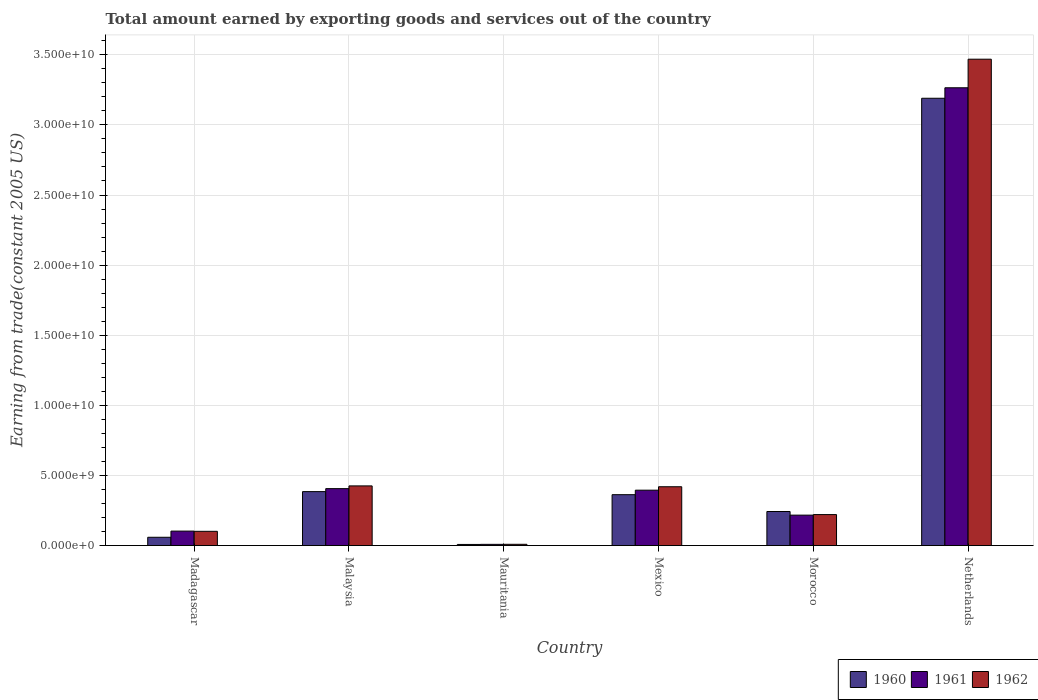How many different coloured bars are there?
Provide a short and direct response. 3. How many groups of bars are there?
Your response must be concise. 6. Are the number of bars on each tick of the X-axis equal?
Offer a terse response. Yes. How many bars are there on the 1st tick from the left?
Give a very brief answer. 3. How many bars are there on the 6th tick from the right?
Your answer should be very brief. 3. What is the label of the 3rd group of bars from the left?
Provide a succinct answer. Mauritania. What is the total amount earned by exporting goods and services in 1962 in Netherlands?
Keep it short and to the point. 3.47e+1. Across all countries, what is the maximum total amount earned by exporting goods and services in 1960?
Provide a short and direct response. 3.19e+1. Across all countries, what is the minimum total amount earned by exporting goods and services in 1962?
Make the answer very short. 8.95e+07. In which country was the total amount earned by exporting goods and services in 1961 maximum?
Provide a succinct answer. Netherlands. In which country was the total amount earned by exporting goods and services in 1961 minimum?
Your answer should be compact. Mauritania. What is the total total amount earned by exporting goods and services in 1961 in the graph?
Your answer should be very brief. 4.39e+1. What is the difference between the total amount earned by exporting goods and services in 1962 in Malaysia and that in Netherlands?
Provide a short and direct response. -3.04e+1. What is the difference between the total amount earned by exporting goods and services in 1961 in Mexico and the total amount earned by exporting goods and services in 1962 in Morocco?
Provide a succinct answer. 1.74e+09. What is the average total amount earned by exporting goods and services in 1961 per country?
Give a very brief answer. 7.32e+09. What is the difference between the total amount earned by exporting goods and services of/in 1960 and total amount earned by exporting goods and services of/in 1961 in Morocco?
Give a very brief answer. 2.59e+08. What is the ratio of the total amount earned by exporting goods and services in 1962 in Mexico to that in Netherlands?
Provide a short and direct response. 0.12. Is the difference between the total amount earned by exporting goods and services in 1960 in Madagascar and Mauritania greater than the difference between the total amount earned by exporting goods and services in 1961 in Madagascar and Mauritania?
Keep it short and to the point. No. What is the difference between the highest and the second highest total amount earned by exporting goods and services in 1961?
Ensure brevity in your answer.  1.10e+08. What is the difference between the highest and the lowest total amount earned by exporting goods and services in 1961?
Ensure brevity in your answer.  3.26e+1. In how many countries, is the total amount earned by exporting goods and services in 1962 greater than the average total amount earned by exporting goods and services in 1962 taken over all countries?
Ensure brevity in your answer.  1. Is the sum of the total amount earned by exporting goods and services in 1960 in Madagascar and Mexico greater than the maximum total amount earned by exporting goods and services in 1962 across all countries?
Keep it short and to the point. No. What does the 3rd bar from the left in Malaysia represents?
Make the answer very short. 1962. How many countries are there in the graph?
Offer a terse response. 6. Does the graph contain any zero values?
Offer a terse response. No. What is the title of the graph?
Ensure brevity in your answer.  Total amount earned by exporting goods and services out of the country. What is the label or title of the Y-axis?
Make the answer very short. Earning from trade(constant 2005 US). What is the Earning from trade(constant 2005 US) in 1960 in Madagascar?
Make the answer very short. 5.92e+08. What is the Earning from trade(constant 2005 US) of 1961 in Madagascar?
Make the answer very short. 1.03e+09. What is the Earning from trade(constant 2005 US) in 1962 in Madagascar?
Make the answer very short. 1.02e+09. What is the Earning from trade(constant 2005 US) of 1960 in Malaysia?
Provide a short and direct response. 3.85e+09. What is the Earning from trade(constant 2005 US) in 1961 in Malaysia?
Offer a very short reply. 4.06e+09. What is the Earning from trade(constant 2005 US) in 1962 in Malaysia?
Provide a succinct answer. 4.25e+09. What is the Earning from trade(constant 2005 US) in 1960 in Mauritania?
Provide a succinct answer. 7.97e+07. What is the Earning from trade(constant 2005 US) of 1961 in Mauritania?
Offer a very short reply. 8.64e+07. What is the Earning from trade(constant 2005 US) in 1962 in Mauritania?
Your response must be concise. 8.95e+07. What is the Earning from trade(constant 2005 US) in 1960 in Mexico?
Your response must be concise. 3.63e+09. What is the Earning from trade(constant 2005 US) of 1961 in Mexico?
Your answer should be compact. 3.95e+09. What is the Earning from trade(constant 2005 US) of 1962 in Mexico?
Provide a short and direct response. 4.19e+09. What is the Earning from trade(constant 2005 US) of 1960 in Morocco?
Provide a succinct answer. 2.43e+09. What is the Earning from trade(constant 2005 US) in 1961 in Morocco?
Keep it short and to the point. 2.17e+09. What is the Earning from trade(constant 2005 US) in 1962 in Morocco?
Give a very brief answer. 2.21e+09. What is the Earning from trade(constant 2005 US) in 1960 in Netherlands?
Ensure brevity in your answer.  3.19e+1. What is the Earning from trade(constant 2005 US) of 1961 in Netherlands?
Offer a terse response. 3.26e+1. What is the Earning from trade(constant 2005 US) of 1962 in Netherlands?
Give a very brief answer. 3.47e+1. Across all countries, what is the maximum Earning from trade(constant 2005 US) in 1960?
Keep it short and to the point. 3.19e+1. Across all countries, what is the maximum Earning from trade(constant 2005 US) of 1961?
Give a very brief answer. 3.26e+1. Across all countries, what is the maximum Earning from trade(constant 2005 US) of 1962?
Your answer should be compact. 3.47e+1. Across all countries, what is the minimum Earning from trade(constant 2005 US) in 1960?
Offer a terse response. 7.97e+07. Across all countries, what is the minimum Earning from trade(constant 2005 US) of 1961?
Your response must be concise. 8.64e+07. Across all countries, what is the minimum Earning from trade(constant 2005 US) of 1962?
Your answer should be very brief. 8.95e+07. What is the total Earning from trade(constant 2005 US) of 1960 in the graph?
Offer a terse response. 4.25e+1. What is the total Earning from trade(constant 2005 US) in 1961 in the graph?
Your answer should be very brief. 4.39e+1. What is the total Earning from trade(constant 2005 US) of 1962 in the graph?
Make the answer very short. 4.64e+1. What is the difference between the Earning from trade(constant 2005 US) of 1960 in Madagascar and that in Malaysia?
Provide a succinct answer. -3.26e+09. What is the difference between the Earning from trade(constant 2005 US) of 1961 in Madagascar and that in Malaysia?
Provide a short and direct response. -3.03e+09. What is the difference between the Earning from trade(constant 2005 US) of 1962 in Madagascar and that in Malaysia?
Your response must be concise. -3.24e+09. What is the difference between the Earning from trade(constant 2005 US) in 1960 in Madagascar and that in Mauritania?
Offer a terse response. 5.12e+08. What is the difference between the Earning from trade(constant 2005 US) in 1961 in Madagascar and that in Mauritania?
Offer a very short reply. 9.45e+08. What is the difference between the Earning from trade(constant 2005 US) in 1962 in Madagascar and that in Mauritania?
Ensure brevity in your answer.  9.26e+08. What is the difference between the Earning from trade(constant 2005 US) in 1960 in Madagascar and that in Mexico?
Offer a very short reply. -3.04e+09. What is the difference between the Earning from trade(constant 2005 US) in 1961 in Madagascar and that in Mexico?
Keep it short and to the point. -2.92e+09. What is the difference between the Earning from trade(constant 2005 US) of 1962 in Madagascar and that in Mexico?
Keep it short and to the point. -3.18e+09. What is the difference between the Earning from trade(constant 2005 US) in 1960 in Madagascar and that in Morocco?
Ensure brevity in your answer.  -1.84e+09. What is the difference between the Earning from trade(constant 2005 US) in 1961 in Madagascar and that in Morocco?
Make the answer very short. -1.14e+09. What is the difference between the Earning from trade(constant 2005 US) of 1962 in Madagascar and that in Morocco?
Your response must be concise. -1.19e+09. What is the difference between the Earning from trade(constant 2005 US) of 1960 in Madagascar and that in Netherlands?
Provide a short and direct response. -3.13e+1. What is the difference between the Earning from trade(constant 2005 US) in 1961 in Madagascar and that in Netherlands?
Provide a short and direct response. -3.16e+1. What is the difference between the Earning from trade(constant 2005 US) in 1962 in Madagascar and that in Netherlands?
Provide a succinct answer. -3.37e+1. What is the difference between the Earning from trade(constant 2005 US) in 1960 in Malaysia and that in Mauritania?
Give a very brief answer. 3.77e+09. What is the difference between the Earning from trade(constant 2005 US) in 1961 in Malaysia and that in Mauritania?
Keep it short and to the point. 3.97e+09. What is the difference between the Earning from trade(constant 2005 US) of 1962 in Malaysia and that in Mauritania?
Offer a very short reply. 4.17e+09. What is the difference between the Earning from trade(constant 2005 US) in 1960 in Malaysia and that in Mexico?
Give a very brief answer. 2.18e+08. What is the difference between the Earning from trade(constant 2005 US) in 1961 in Malaysia and that in Mexico?
Your answer should be compact. 1.10e+08. What is the difference between the Earning from trade(constant 2005 US) in 1962 in Malaysia and that in Mexico?
Provide a succinct answer. 6.04e+07. What is the difference between the Earning from trade(constant 2005 US) of 1960 in Malaysia and that in Morocco?
Give a very brief answer. 1.42e+09. What is the difference between the Earning from trade(constant 2005 US) in 1961 in Malaysia and that in Morocco?
Your answer should be compact. 1.89e+09. What is the difference between the Earning from trade(constant 2005 US) in 1962 in Malaysia and that in Morocco?
Keep it short and to the point. 2.05e+09. What is the difference between the Earning from trade(constant 2005 US) in 1960 in Malaysia and that in Netherlands?
Provide a short and direct response. -2.81e+1. What is the difference between the Earning from trade(constant 2005 US) of 1961 in Malaysia and that in Netherlands?
Offer a terse response. -2.86e+1. What is the difference between the Earning from trade(constant 2005 US) of 1962 in Malaysia and that in Netherlands?
Make the answer very short. -3.04e+1. What is the difference between the Earning from trade(constant 2005 US) of 1960 in Mauritania and that in Mexico?
Make the answer very short. -3.55e+09. What is the difference between the Earning from trade(constant 2005 US) of 1961 in Mauritania and that in Mexico?
Provide a succinct answer. -3.86e+09. What is the difference between the Earning from trade(constant 2005 US) of 1962 in Mauritania and that in Mexico?
Keep it short and to the point. -4.10e+09. What is the difference between the Earning from trade(constant 2005 US) of 1960 in Mauritania and that in Morocco?
Your response must be concise. -2.35e+09. What is the difference between the Earning from trade(constant 2005 US) of 1961 in Mauritania and that in Morocco?
Give a very brief answer. -2.08e+09. What is the difference between the Earning from trade(constant 2005 US) of 1962 in Mauritania and that in Morocco?
Your response must be concise. -2.12e+09. What is the difference between the Earning from trade(constant 2005 US) of 1960 in Mauritania and that in Netherlands?
Your answer should be compact. -3.18e+1. What is the difference between the Earning from trade(constant 2005 US) in 1961 in Mauritania and that in Netherlands?
Offer a terse response. -3.26e+1. What is the difference between the Earning from trade(constant 2005 US) of 1962 in Mauritania and that in Netherlands?
Make the answer very short. -3.46e+1. What is the difference between the Earning from trade(constant 2005 US) of 1960 in Mexico and that in Morocco?
Make the answer very short. 1.20e+09. What is the difference between the Earning from trade(constant 2005 US) in 1961 in Mexico and that in Morocco?
Give a very brief answer. 1.78e+09. What is the difference between the Earning from trade(constant 2005 US) in 1962 in Mexico and that in Morocco?
Ensure brevity in your answer.  1.99e+09. What is the difference between the Earning from trade(constant 2005 US) of 1960 in Mexico and that in Netherlands?
Ensure brevity in your answer.  -2.83e+1. What is the difference between the Earning from trade(constant 2005 US) in 1961 in Mexico and that in Netherlands?
Offer a terse response. -2.87e+1. What is the difference between the Earning from trade(constant 2005 US) of 1962 in Mexico and that in Netherlands?
Offer a very short reply. -3.05e+1. What is the difference between the Earning from trade(constant 2005 US) of 1960 in Morocco and that in Netherlands?
Offer a very short reply. -2.95e+1. What is the difference between the Earning from trade(constant 2005 US) of 1961 in Morocco and that in Netherlands?
Ensure brevity in your answer.  -3.05e+1. What is the difference between the Earning from trade(constant 2005 US) in 1962 in Morocco and that in Netherlands?
Ensure brevity in your answer.  -3.25e+1. What is the difference between the Earning from trade(constant 2005 US) of 1960 in Madagascar and the Earning from trade(constant 2005 US) of 1961 in Malaysia?
Ensure brevity in your answer.  -3.47e+09. What is the difference between the Earning from trade(constant 2005 US) of 1960 in Madagascar and the Earning from trade(constant 2005 US) of 1962 in Malaysia?
Ensure brevity in your answer.  -3.66e+09. What is the difference between the Earning from trade(constant 2005 US) in 1961 in Madagascar and the Earning from trade(constant 2005 US) in 1962 in Malaysia?
Offer a terse response. -3.22e+09. What is the difference between the Earning from trade(constant 2005 US) of 1960 in Madagascar and the Earning from trade(constant 2005 US) of 1961 in Mauritania?
Provide a succinct answer. 5.05e+08. What is the difference between the Earning from trade(constant 2005 US) in 1960 in Madagascar and the Earning from trade(constant 2005 US) in 1962 in Mauritania?
Keep it short and to the point. 5.02e+08. What is the difference between the Earning from trade(constant 2005 US) in 1961 in Madagascar and the Earning from trade(constant 2005 US) in 1962 in Mauritania?
Your answer should be compact. 9.42e+08. What is the difference between the Earning from trade(constant 2005 US) of 1960 in Madagascar and the Earning from trade(constant 2005 US) of 1961 in Mexico?
Provide a short and direct response. -3.36e+09. What is the difference between the Earning from trade(constant 2005 US) in 1960 in Madagascar and the Earning from trade(constant 2005 US) in 1962 in Mexico?
Offer a terse response. -3.60e+09. What is the difference between the Earning from trade(constant 2005 US) in 1961 in Madagascar and the Earning from trade(constant 2005 US) in 1962 in Mexico?
Provide a succinct answer. -3.16e+09. What is the difference between the Earning from trade(constant 2005 US) in 1960 in Madagascar and the Earning from trade(constant 2005 US) in 1961 in Morocco?
Your answer should be very brief. -1.58e+09. What is the difference between the Earning from trade(constant 2005 US) of 1960 in Madagascar and the Earning from trade(constant 2005 US) of 1962 in Morocco?
Offer a very short reply. -1.62e+09. What is the difference between the Earning from trade(constant 2005 US) in 1961 in Madagascar and the Earning from trade(constant 2005 US) in 1962 in Morocco?
Offer a terse response. -1.18e+09. What is the difference between the Earning from trade(constant 2005 US) in 1960 in Madagascar and the Earning from trade(constant 2005 US) in 1961 in Netherlands?
Your response must be concise. -3.21e+1. What is the difference between the Earning from trade(constant 2005 US) in 1960 in Madagascar and the Earning from trade(constant 2005 US) in 1962 in Netherlands?
Your response must be concise. -3.41e+1. What is the difference between the Earning from trade(constant 2005 US) in 1961 in Madagascar and the Earning from trade(constant 2005 US) in 1962 in Netherlands?
Your response must be concise. -3.37e+1. What is the difference between the Earning from trade(constant 2005 US) of 1960 in Malaysia and the Earning from trade(constant 2005 US) of 1961 in Mauritania?
Your answer should be very brief. 3.76e+09. What is the difference between the Earning from trade(constant 2005 US) of 1960 in Malaysia and the Earning from trade(constant 2005 US) of 1962 in Mauritania?
Provide a short and direct response. 3.76e+09. What is the difference between the Earning from trade(constant 2005 US) in 1961 in Malaysia and the Earning from trade(constant 2005 US) in 1962 in Mauritania?
Offer a terse response. 3.97e+09. What is the difference between the Earning from trade(constant 2005 US) of 1960 in Malaysia and the Earning from trade(constant 2005 US) of 1961 in Mexico?
Your answer should be compact. -1.02e+08. What is the difference between the Earning from trade(constant 2005 US) of 1960 in Malaysia and the Earning from trade(constant 2005 US) of 1962 in Mexico?
Offer a very short reply. -3.48e+08. What is the difference between the Earning from trade(constant 2005 US) in 1961 in Malaysia and the Earning from trade(constant 2005 US) in 1962 in Mexico?
Provide a short and direct response. -1.35e+08. What is the difference between the Earning from trade(constant 2005 US) of 1960 in Malaysia and the Earning from trade(constant 2005 US) of 1961 in Morocco?
Your answer should be compact. 1.68e+09. What is the difference between the Earning from trade(constant 2005 US) in 1960 in Malaysia and the Earning from trade(constant 2005 US) in 1962 in Morocco?
Your answer should be very brief. 1.64e+09. What is the difference between the Earning from trade(constant 2005 US) in 1961 in Malaysia and the Earning from trade(constant 2005 US) in 1962 in Morocco?
Offer a terse response. 1.85e+09. What is the difference between the Earning from trade(constant 2005 US) of 1960 in Malaysia and the Earning from trade(constant 2005 US) of 1961 in Netherlands?
Provide a short and direct response. -2.88e+1. What is the difference between the Earning from trade(constant 2005 US) of 1960 in Malaysia and the Earning from trade(constant 2005 US) of 1962 in Netherlands?
Your answer should be very brief. -3.08e+1. What is the difference between the Earning from trade(constant 2005 US) of 1961 in Malaysia and the Earning from trade(constant 2005 US) of 1962 in Netherlands?
Provide a short and direct response. -3.06e+1. What is the difference between the Earning from trade(constant 2005 US) in 1960 in Mauritania and the Earning from trade(constant 2005 US) in 1961 in Mexico?
Offer a very short reply. -3.87e+09. What is the difference between the Earning from trade(constant 2005 US) of 1960 in Mauritania and the Earning from trade(constant 2005 US) of 1962 in Mexico?
Provide a short and direct response. -4.11e+09. What is the difference between the Earning from trade(constant 2005 US) of 1961 in Mauritania and the Earning from trade(constant 2005 US) of 1962 in Mexico?
Make the answer very short. -4.11e+09. What is the difference between the Earning from trade(constant 2005 US) of 1960 in Mauritania and the Earning from trade(constant 2005 US) of 1961 in Morocco?
Make the answer very short. -2.09e+09. What is the difference between the Earning from trade(constant 2005 US) in 1960 in Mauritania and the Earning from trade(constant 2005 US) in 1962 in Morocco?
Your answer should be compact. -2.13e+09. What is the difference between the Earning from trade(constant 2005 US) in 1961 in Mauritania and the Earning from trade(constant 2005 US) in 1962 in Morocco?
Keep it short and to the point. -2.12e+09. What is the difference between the Earning from trade(constant 2005 US) of 1960 in Mauritania and the Earning from trade(constant 2005 US) of 1961 in Netherlands?
Keep it short and to the point. -3.26e+1. What is the difference between the Earning from trade(constant 2005 US) of 1960 in Mauritania and the Earning from trade(constant 2005 US) of 1962 in Netherlands?
Offer a very short reply. -3.46e+1. What is the difference between the Earning from trade(constant 2005 US) of 1961 in Mauritania and the Earning from trade(constant 2005 US) of 1962 in Netherlands?
Your answer should be compact. -3.46e+1. What is the difference between the Earning from trade(constant 2005 US) of 1960 in Mexico and the Earning from trade(constant 2005 US) of 1961 in Morocco?
Offer a very short reply. 1.46e+09. What is the difference between the Earning from trade(constant 2005 US) of 1960 in Mexico and the Earning from trade(constant 2005 US) of 1962 in Morocco?
Keep it short and to the point. 1.42e+09. What is the difference between the Earning from trade(constant 2005 US) of 1961 in Mexico and the Earning from trade(constant 2005 US) of 1962 in Morocco?
Provide a short and direct response. 1.74e+09. What is the difference between the Earning from trade(constant 2005 US) in 1960 in Mexico and the Earning from trade(constant 2005 US) in 1961 in Netherlands?
Your answer should be very brief. -2.90e+1. What is the difference between the Earning from trade(constant 2005 US) of 1960 in Mexico and the Earning from trade(constant 2005 US) of 1962 in Netherlands?
Your response must be concise. -3.11e+1. What is the difference between the Earning from trade(constant 2005 US) of 1961 in Mexico and the Earning from trade(constant 2005 US) of 1962 in Netherlands?
Make the answer very short. -3.07e+1. What is the difference between the Earning from trade(constant 2005 US) of 1960 in Morocco and the Earning from trade(constant 2005 US) of 1961 in Netherlands?
Give a very brief answer. -3.02e+1. What is the difference between the Earning from trade(constant 2005 US) in 1960 in Morocco and the Earning from trade(constant 2005 US) in 1962 in Netherlands?
Keep it short and to the point. -3.23e+1. What is the difference between the Earning from trade(constant 2005 US) of 1961 in Morocco and the Earning from trade(constant 2005 US) of 1962 in Netherlands?
Provide a succinct answer. -3.25e+1. What is the average Earning from trade(constant 2005 US) of 1960 per country?
Offer a terse response. 7.08e+09. What is the average Earning from trade(constant 2005 US) of 1961 per country?
Ensure brevity in your answer.  7.32e+09. What is the average Earning from trade(constant 2005 US) in 1962 per country?
Your response must be concise. 7.74e+09. What is the difference between the Earning from trade(constant 2005 US) of 1960 and Earning from trade(constant 2005 US) of 1961 in Madagascar?
Provide a short and direct response. -4.40e+08. What is the difference between the Earning from trade(constant 2005 US) of 1960 and Earning from trade(constant 2005 US) of 1962 in Madagascar?
Your answer should be compact. -4.24e+08. What is the difference between the Earning from trade(constant 2005 US) of 1961 and Earning from trade(constant 2005 US) of 1962 in Madagascar?
Give a very brief answer. 1.61e+07. What is the difference between the Earning from trade(constant 2005 US) of 1960 and Earning from trade(constant 2005 US) of 1961 in Malaysia?
Your answer should be very brief. -2.13e+08. What is the difference between the Earning from trade(constant 2005 US) in 1960 and Earning from trade(constant 2005 US) in 1962 in Malaysia?
Offer a very short reply. -4.08e+08. What is the difference between the Earning from trade(constant 2005 US) of 1961 and Earning from trade(constant 2005 US) of 1962 in Malaysia?
Ensure brevity in your answer.  -1.95e+08. What is the difference between the Earning from trade(constant 2005 US) of 1960 and Earning from trade(constant 2005 US) of 1961 in Mauritania?
Provide a short and direct response. -6.74e+06. What is the difference between the Earning from trade(constant 2005 US) of 1960 and Earning from trade(constant 2005 US) of 1962 in Mauritania?
Your answer should be very brief. -9.81e+06. What is the difference between the Earning from trade(constant 2005 US) of 1961 and Earning from trade(constant 2005 US) of 1962 in Mauritania?
Your answer should be compact. -3.07e+06. What is the difference between the Earning from trade(constant 2005 US) of 1960 and Earning from trade(constant 2005 US) of 1961 in Mexico?
Ensure brevity in your answer.  -3.21e+08. What is the difference between the Earning from trade(constant 2005 US) in 1960 and Earning from trade(constant 2005 US) in 1962 in Mexico?
Provide a short and direct response. -5.66e+08. What is the difference between the Earning from trade(constant 2005 US) of 1961 and Earning from trade(constant 2005 US) of 1962 in Mexico?
Give a very brief answer. -2.45e+08. What is the difference between the Earning from trade(constant 2005 US) in 1960 and Earning from trade(constant 2005 US) in 1961 in Morocco?
Make the answer very short. 2.59e+08. What is the difference between the Earning from trade(constant 2005 US) of 1960 and Earning from trade(constant 2005 US) of 1962 in Morocco?
Ensure brevity in your answer.  2.19e+08. What is the difference between the Earning from trade(constant 2005 US) in 1961 and Earning from trade(constant 2005 US) in 1962 in Morocco?
Provide a succinct answer. -3.93e+07. What is the difference between the Earning from trade(constant 2005 US) of 1960 and Earning from trade(constant 2005 US) of 1961 in Netherlands?
Your answer should be very brief. -7.48e+08. What is the difference between the Earning from trade(constant 2005 US) in 1960 and Earning from trade(constant 2005 US) in 1962 in Netherlands?
Offer a very short reply. -2.79e+09. What is the difference between the Earning from trade(constant 2005 US) of 1961 and Earning from trade(constant 2005 US) of 1962 in Netherlands?
Your answer should be very brief. -2.04e+09. What is the ratio of the Earning from trade(constant 2005 US) in 1960 in Madagascar to that in Malaysia?
Your response must be concise. 0.15. What is the ratio of the Earning from trade(constant 2005 US) of 1961 in Madagascar to that in Malaysia?
Your response must be concise. 0.25. What is the ratio of the Earning from trade(constant 2005 US) of 1962 in Madagascar to that in Malaysia?
Make the answer very short. 0.24. What is the ratio of the Earning from trade(constant 2005 US) in 1960 in Madagascar to that in Mauritania?
Make the answer very short. 7.42. What is the ratio of the Earning from trade(constant 2005 US) in 1961 in Madagascar to that in Mauritania?
Your response must be concise. 11.93. What is the ratio of the Earning from trade(constant 2005 US) in 1962 in Madagascar to that in Mauritania?
Provide a short and direct response. 11.34. What is the ratio of the Earning from trade(constant 2005 US) in 1960 in Madagascar to that in Mexico?
Ensure brevity in your answer.  0.16. What is the ratio of the Earning from trade(constant 2005 US) of 1961 in Madagascar to that in Mexico?
Give a very brief answer. 0.26. What is the ratio of the Earning from trade(constant 2005 US) in 1962 in Madagascar to that in Mexico?
Keep it short and to the point. 0.24. What is the ratio of the Earning from trade(constant 2005 US) of 1960 in Madagascar to that in Morocco?
Your answer should be very brief. 0.24. What is the ratio of the Earning from trade(constant 2005 US) in 1961 in Madagascar to that in Morocco?
Offer a terse response. 0.48. What is the ratio of the Earning from trade(constant 2005 US) of 1962 in Madagascar to that in Morocco?
Provide a short and direct response. 0.46. What is the ratio of the Earning from trade(constant 2005 US) in 1960 in Madagascar to that in Netherlands?
Ensure brevity in your answer.  0.02. What is the ratio of the Earning from trade(constant 2005 US) in 1961 in Madagascar to that in Netherlands?
Your answer should be very brief. 0.03. What is the ratio of the Earning from trade(constant 2005 US) in 1962 in Madagascar to that in Netherlands?
Offer a very short reply. 0.03. What is the ratio of the Earning from trade(constant 2005 US) of 1960 in Malaysia to that in Mauritania?
Your answer should be very brief. 48.26. What is the ratio of the Earning from trade(constant 2005 US) of 1961 in Malaysia to that in Mauritania?
Your answer should be very brief. 46.96. What is the ratio of the Earning from trade(constant 2005 US) of 1962 in Malaysia to that in Mauritania?
Ensure brevity in your answer.  47.53. What is the ratio of the Earning from trade(constant 2005 US) of 1960 in Malaysia to that in Mexico?
Offer a terse response. 1.06. What is the ratio of the Earning from trade(constant 2005 US) of 1961 in Malaysia to that in Mexico?
Your response must be concise. 1.03. What is the ratio of the Earning from trade(constant 2005 US) of 1962 in Malaysia to that in Mexico?
Make the answer very short. 1.01. What is the ratio of the Earning from trade(constant 2005 US) of 1960 in Malaysia to that in Morocco?
Provide a short and direct response. 1.58. What is the ratio of the Earning from trade(constant 2005 US) in 1961 in Malaysia to that in Morocco?
Ensure brevity in your answer.  1.87. What is the ratio of the Earning from trade(constant 2005 US) in 1962 in Malaysia to that in Morocco?
Your response must be concise. 1.93. What is the ratio of the Earning from trade(constant 2005 US) in 1960 in Malaysia to that in Netherlands?
Ensure brevity in your answer.  0.12. What is the ratio of the Earning from trade(constant 2005 US) of 1961 in Malaysia to that in Netherlands?
Your answer should be very brief. 0.12. What is the ratio of the Earning from trade(constant 2005 US) in 1962 in Malaysia to that in Netherlands?
Give a very brief answer. 0.12. What is the ratio of the Earning from trade(constant 2005 US) of 1960 in Mauritania to that in Mexico?
Ensure brevity in your answer.  0.02. What is the ratio of the Earning from trade(constant 2005 US) of 1961 in Mauritania to that in Mexico?
Ensure brevity in your answer.  0.02. What is the ratio of the Earning from trade(constant 2005 US) of 1962 in Mauritania to that in Mexico?
Provide a short and direct response. 0.02. What is the ratio of the Earning from trade(constant 2005 US) in 1960 in Mauritania to that in Morocco?
Your response must be concise. 0.03. What is the ratio of the Earning from trade(constant 2005 US) in 1961 in Mauritania to that in Morocco?
Provide a short and direct response. 0.04. What is the ratio of the Earning from trade(constant 2005 US) in 1962 in Mauritania to that in Morocco?
Offer a very short reply. 0.04. What is the ratio of the Earning from trade(constant 2005 US) in 1960 in Mauritania to that in Netherlands?
Ensure brevity in your answer.  0. What is the ratio of the Earning from trade(constant 2005 US) in 1961 in Mauritania to that in Netherlands?
Offer a very short reply. 0. What is the ratio of the Earning from trade(constant 2005 US) in 1962 in Mauritania to that in Netherlands?
Provide a short and direct response. 0. What is the ratio of the Earning from trade(constant 2005 US) in 1960 in Mexico to that in Morocco?
Offer a very short reply. 1.49. What is the ratio of the Earning from trade(constant 2005 US) of 1961 in Mexico to that in Morocco?
Provide a succinct answer. 1.82. What is the ratio of the Earning from trade(constant 2005 US) of 1962 in Mexico to that in Morocco?
Give a very brief answer. 1.9. What is the ratio of the Earning from trade(constant 2005 US) in 1960 in Mexico to that in Netherlands?
Your answer should be very brief. 0.11. What is the ratio of the Earning from trade(constant 2005 US) in 1961 in Mexico to that in Netherlands?
Provide a succinct answer. 0.12. What is the ratio of the Earning from trade(constant 2005 US) of 1962 in Mexico to that in Netherlands?
Provide a succinct answer. 0.12. What is the ratio of the Earning from trade(constant 2005 US) of 1960 in Morocco to that in Netherlands?
Give a very brief answer. 0.08. What is the ratio of the Earning from trade(constant 2005 US) in 1961 in Morocco to that in Netherlands?
Ensure brevity in your answer.  0.07. What is the ratio of the Earning from trade(constant 2005 US) of 1962 in Morocco to that in Netherlands?
Make the answer very short. 0.06. What is the difference between the highest and the second highest Earning from trade(constant 2005 US) of 1960?
Ensure brevity in your answer.  2.81e+1. What is the difference between the highest and the second highest Earning from trade(constant 2005 US) in 1961?
Your answer should be very brief. 2.86e+1. What is the difference between the highest and the second highest Earning from trade(constant 2005 US) in 1962?
Offer a very short reply. 3.04e+1. What is the difference between the highest and the lowest Earning from trade(constant 2005 US) in 1960?
Offer a terse response. 3.18e+1. What is the difference between the highest and the lowest Earning from trade(constant 2005 US) in 1961?
Provide a short and direct response. 3.26e+1. What is the difference between the highest and the lowest Earning from trade(constant 2005 US) in 1962?
Offer a terse response. 3.46e+1. 